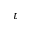<formula> <loc_0><loc_0><loc_500><loc_500>\tau</formula> 